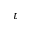<formula> <loc_0><loc_0><loc_500><loc_500>\tau</formula> 